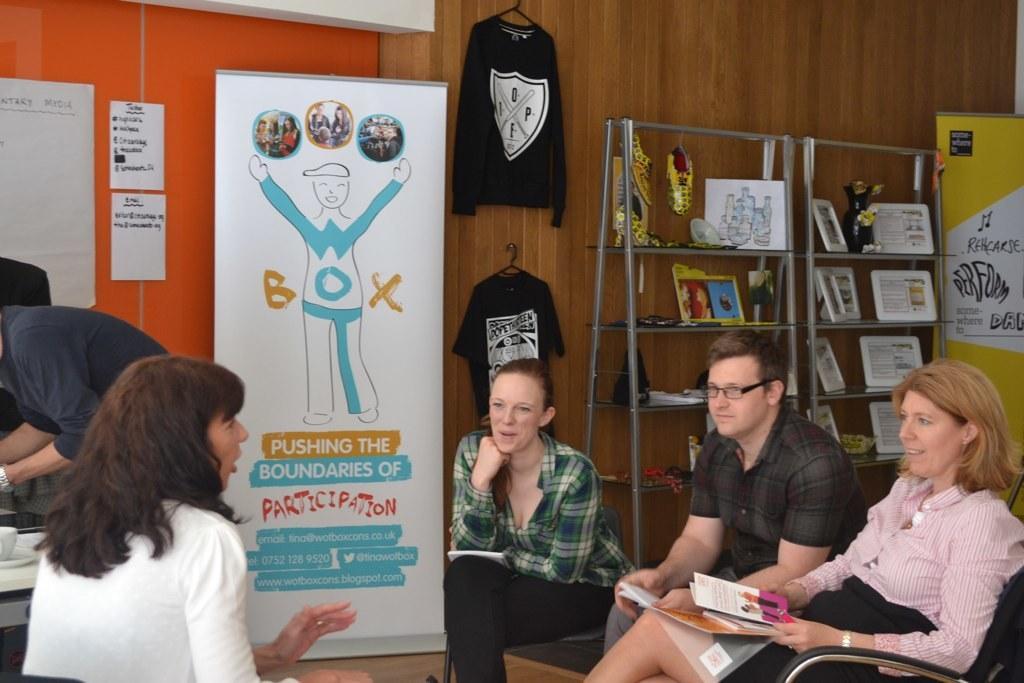Could you give a brief overview of what you see in this image? In this image we can see some group of persons sitting on chairs discussing between themselves and in the background of the image there are some items arranged in shelves, there is a T-shirt which is hanged, there are some boards and a wall. 